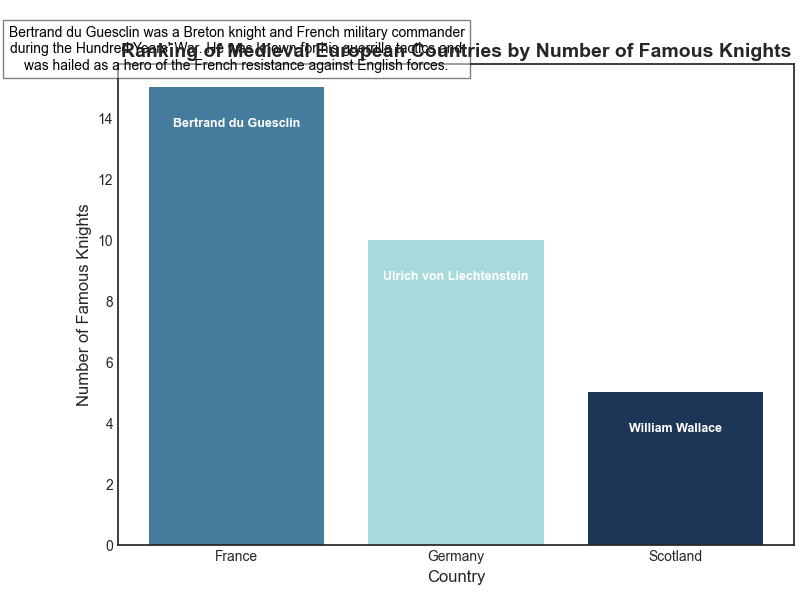What country has the highest number of famous knights? France has the highest bar, indicating it has the most famous knights.
Answer: France Which country has the fewest famous knights? Scotland has the shortest bar, indicating it has the fewest famous knights.
Answer: Scotland What's the difference in the number of famous knights between France and Germany? France has 15 famous knights and Germany has 10. The difference is 15 - 10 = 5.
Answer: 5 What is the total number of famous knights across all countries listed? Summing the values: 15 (France) + 10 (Germany) + 5 (Scotland) = 30.
Answer: 30 Which country's top knight is associated with guerrilla tactics during the Hundred Years' War? The biographical note for Bertrand du Guesclin of France mentions guerrilla tactics during the Hundred Years' War.
Answer: France What country has a top knight known for his autobiographical writings? The biographical note for Ulrich von Liechtenstein of Germany mentions his autobiographical writings.
Answer: Germany How many more famous knights does France have compared to Scotland? France has 15 famous knights and Scotland has 5. The difference is 15 - 5 = 10.
Answer: 10 Which bar is colored dark blue? The bar representing Germany is colored dark blue.
Answer: Germany Who is the top knight for Scotland? The bar labeled for Scotland has "William Wallace" noted on it.
Answer: William Wallace What is the biographical note for the top knight of the country with 10 famous knights? The biographical note next to the bar for Germany (which has 10 knights) is for Ulrich von Liechtenstein, describing his writings and legacy.
Answer: Ulrich von Liechtenstein was a nobleman and knight from Styria. He is best remembered for his autobiographical and frankly self-promotional writings that offer a unique glimpse into medieval knighthood 